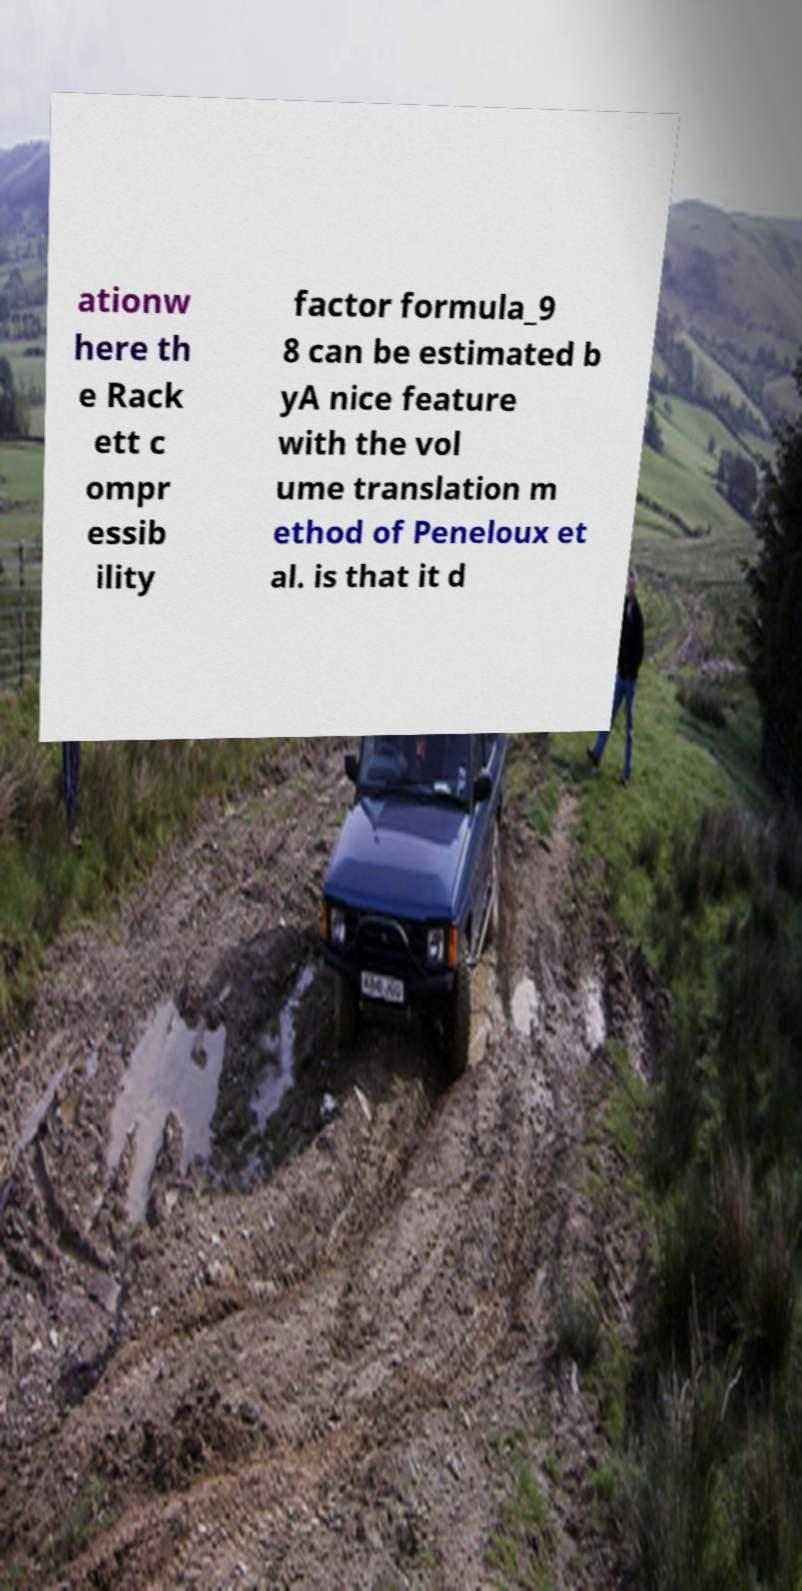Can you read and provide the text displayed in the image?This photo seems to have some interesting text. Can you extract and type it out for me? ationw here th e Rack ett c ompr essib ility factor formula_9 8 can be estimated b yA nice feature with the vol ume translation m ethod of Peneloux et al. is that it d 